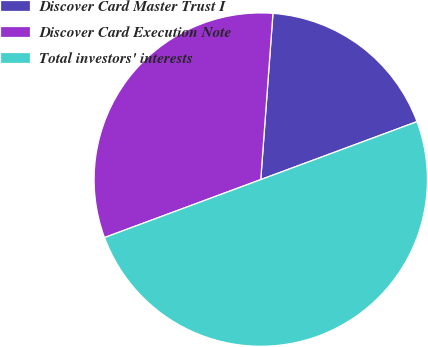Convert chart. <chart><loc_0><loc_0><loc_500><loc_500><pie_chart><fcel>Discover Card Master Trust I<fcel>Discover Card Execution Note<fcel>Total investors' interests<nl><fcel>18.18%<fcel>31.82%<fcel>50.0%<nl></chart> 